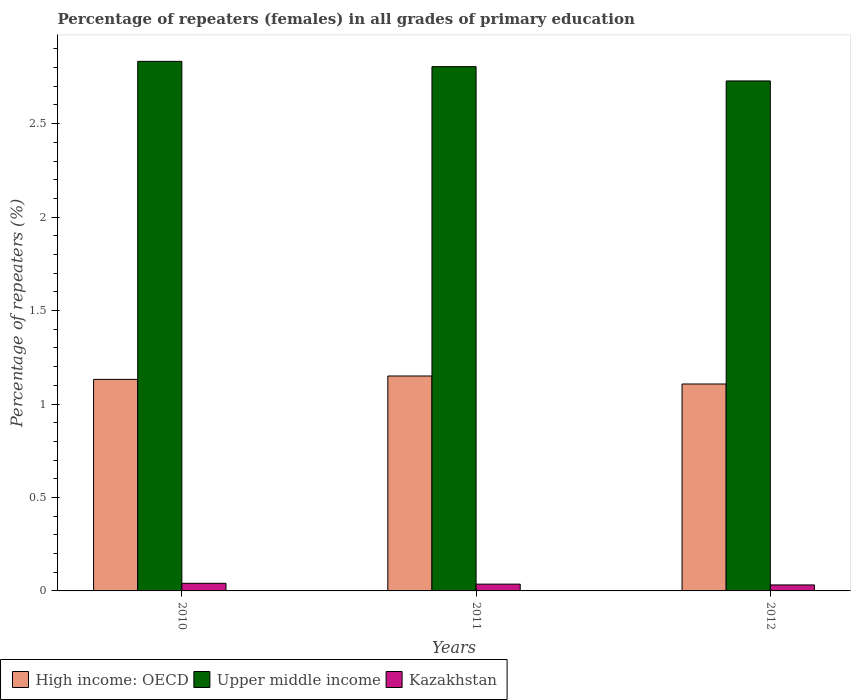How many different coloured bars are there?
Give a very brief answer. 3. What is the label of the 2nd group of bars from the left?
Ensure brevity in your answer.  2011. What is the percentage of repeaters (females) in High income: OECD in 2010?
Your answer should be compact. 1.13. Across all years, what is the maximum percentage of repeaters (females) in Upper middle income?
Give a very brief answer. 2.83. Across all years, what is the minimum percentage of repeaters (females) in Kazakhstan?
Your answer should be compact. 0.03. What is the total percentage of repeaters (females) in Kazakhstan in the graph?
Offer a terse response. 0.11. What is the difference between the percentage of repeaters (females) in Upper middle income in 2011 and that in 2012?
Ensure brevity in your answer.  0.08. What is the difference between the percentage of repeaters (females) in Kazakhstan in 2010 and the percentage of repeaters (females) in High income: OECD in 2012?
Make the answer very short. -1.07. What is the average percentage of repeaters (females) in Upper middle income per year?
Provide a short and direct response. 2.79. In the year 2012, what is the difference between the percentage of repeaters (females) in Upper middle income and percentage of repeaters (females) in High income: OECD?
Keep it short and to the point. 1.62. In how many years, is the percentage of repeaters (females) in Kazakhstan greater than 1.9 %?
Keep it short and to the point. 0. What is the ratio of the percentage of repeaters (females) in Kazakhstan in 2010 to that in 2012?
Keep it short and to the point. 1.27. What is the difference between the highest and the second highest percentage of repeaters (females) in Kazakhstan?
Your response must be concise. 0. What is the difference between the highest and the lowest percentage of repeaters (females) in High income: OECD?
Make the answer very short. 0.04. In how many years, is the percentage of repeaters (females) in Kazakhstan greater than the average percentage of repeaters (females) in Kazakhstan taken over all years?
Keep it short and to the point. 1. Is the sum of the percentage of repeaters (females) in Upper middle income in 2011 and 2012 greater than the maximum percentage of repeaters (females) in Kazakhstan across all years?
Your response must be concise. Yes. What does the 3rd bar from the left in 2011 represents?
Make the answer very short. Kazakhstan. What does the 2nd bar from the right in 2012 represents?
Your response must be concise. Upper middle income. Is it the case that in every year, the sum of the percentage of repeaters (females) in High income: OECD and percentage of repeaters (females) in Upper middle income is greater than the percentage of repeaters (females) in Kazakhstan?
Your answer should be compact. Yes. How many years are there in the graph?
Give a very brief answer. 3. What is the difference between two consecutive major ticks on the Y-axis?
Offer a terse response. 0.5. Does the graph contain any zero values?
Give a very brief answer. No. Does the graph contain grids?
Keep it short and to the point. No. How are the legend labels stacked?
Provide a succinct answer. Horizontal. What is the title of the graph?
Offer a very short reply. Percentage of repeaters (females) in all grades of primary education. Does "Cuba" appear as one of the legend labels in the graph?
Make the answer very short. No. What is the label or title of the X-axis?
Offer a very short reply. Years. What is the label or title of the Y-axis?
Provide a succinct answer. Percentage of repeaters (%). What is the Percentage of repeaters (%) in High income: OECD in 2010?
Your response must be concise. 1.13. What is the Percentage of repeaters (%) of Upper middle income in 2010?
Make the answer very short. 2.83. What is the Percentage of repeaters (%) of Kazakhstan in 2010?
Your answer should be very brief. 0.04. What is the Percentage of repeaters (%) of High income: OECD in 2011?
Your answer should be compact. 1.15. What is the Percentage of repeaters (%) of Upper middle income in 2011?
Provide a succinct answer. 2.81. What is the Percentage of repeaters (%) of Kazakhstan in 2011?
Ensure brevity in your answer.  0.04. What is the Percentage of repeaters (%) of High income: OECD in 2012?
Keep it short and to the point. 1.11. What is the Percentage of repeaters (%) in Upper middle income in 2012?
Make the answer very short. 2.73. What is the Percentage of repeaters (%) in Kazakhstan in 2012?
Your response must be concise. 0.03. Across all years, what is the maximum Percentage of repeaters (%) in High income: OECD?
Make the answer very short. 1.15. Across all years, what is the maximum Percentage of repeaters (%) of Upper middle income?
Provide a succinct answer. 2.83. Across all years, what is the maximum Percentage of repeaters (%) in Kazakhstan?
Offer a very short reply. 0.04. Across all years, what is the minimum Percentage of repeaters (%) of High income: OECD?
Your answer should be very brief. 1.11. Across all years, what is the minimum Percentage of repeaters (%) in Upper middle income?
Ensure brevity in your answer.  2.73. Across all years, what is the minimum Percentage of repeaters (%) of Kazakhstan?
Your answer should be compact. 0.03. What is the total Percentage of repeaters (%) of High income: OECD in the graph?
Offer a terse response. 3.39. What is the total Percentage of repeaters (%) in Upper middle income in the graph?
Offer a terse response. 8.37. What is the total Percentage of repeaters (%) in Kazakhstan in the graph?
Provide a short and direct response. 0.11. What is the difference between the Percentage of repeaters (%) in High income: OECD in 2010 and that in 2011?
Offer a terse response. -0.02. What is the difference between the Percentage of repeaters (%) of Upper middle income in 2010 and that in 2011?
Ensure brevity in your answer.  0.03. What is the difference between the Percentage of repeaters (%) in Kazakhstan in 2010 and that in 2011?
Provide a succinct answer. 0. What is the difference between the Percentage of repeaters (%) of High income: OECD in 2010 and that in 2012?
Provide a succinct answer. 0.02. What is the difference between the Percentage of repeaters (%) of Upper middle income in 2010 and that in 2012?
Keep it short and to the point. 0.1. What is the difference between the Percentage of repeaters (%) of Kazakhstan in 2010 and that in 2012?
Ensure brevity in your answer.  0.01. What is the difference between the Percentage of repeaters (%) in High income: OECD in 2011 and that in 2012?
Your answer should be compact. 0.04. What is the difference between the Percentage of repeaters (%) in Upper middle income in 2011 and that in 2012?
Your response must be concise. 0.08. What is the difference between the Percentage of repeaters (%) of Kazakhstan in 2011 and that in 2012?
Your answer should be very brief. 0. What is the difference between the Percentage of repeaters (%) in High income: OECD in 2010 and the Percentage of repeaters (%) in Upper middle income in 2011?
Provide a short and direct response. -1.67. What is the difference between the Percentage of repeaters (%) of High income: OECD in 2010 and the Percentage of repeaters (%) of Kazakhstan in 2011?
Your response must be concise. 1.1. What is the difference between the Percentage of repeaters (%) in Upper middle income in 2010 and the Percentage of repeaters (%) in Kazakhstan in 2011?
Offer a terse response. 2.8. What is the difference between the Percentage of repeaters (%) of High income: OECD in 2010 and the Percentage of repeaters (%) of Upper middle income in 2012?
Provide a succinct answer. -1.6. What is the difference between the Percentage of repeaters (%) in High income: OECD in 2010 and the Percentage of repeaters (%) in Kazakhstan in 2012?
Give a very brief answer. 1.1. What is the difference between the Percentage of repeaters (%) of Upper middle income in 2010 and the Percentage of repeaters (%) of Kazakhstan in 2012?
Your answer should be very brief. 2.8. What is the difference between the Percentage of repeaters (%) of High income: OECD in 2011 and the Percentage of repeaters (%) of Upper middle income in 2012?
Make the answer very short. -1.58. What is the difference between the Percentage of repeaters (%) in High income: OECD in 2011 and the Percentage of repeaters (%) in Kazakhstan in 2012?
Offer a terse response. 1.12. What is the difference between the Percentage of repeaters (%) of Upper middle income in 2011 and the Percentage of repeaters (%) of Kazakhstan in 2012?
Your response must be concise. 2.77. What is the average Percentage of repeaters (%) of High income: OECD per year?
Offer a very short reply. 1.13. What is the average Percentage of repeaters (%) of Upper middle income per year?
Your response must be concise. 2.79. What is the average Percentage of repeaters (%) in Kazakhstan per year?
Make the answer very short. 0.04. In the year 2010, what is the difference between the Percentage of repeaters (%) of High income: OECD and Percentage of repeaters (%) of Upper middle income?
Ensure brevity in your answer.  -1.7. In the year 2010, what is the difference between the Percentage of repeaters (%) of High income: OECD and Percentage of repeaters (%) of Kazakhstan?
Ensure brevity in your answer.  1.09. In the year 2010, what is the difference between the Percentage of repeaters (%) of Upper middle income and Percentage of repeaters (%) of Kazakhstan?
Offer a very short reply. 2.79. In the year 2011, what is the difference between the Percentage of repeaters (%) in High income: OECD and Percentage of repeaters (%) in Upper middle income?
Give a very brief answer. -1.66. In the year 2011, what is the difference between the Percentage of repeaters (%) in High income: OECD and Percentage of repeaters (%) in Kazakhstan?
Ensure brevity in your answer.  1.11. In the year 2011, what is the difference between the Percentage of repeaters (%) in Upper middle income and Percentage of repeaters (%) in Kazakhstan?
Ensure brevity in your answer.  2.77. In the year 2012, what is the difference between the Percentage of repeaters (%) of High income: OECD and Percentage of repeaters (%) of Upper middle income?
Offer a very short reply. -1.62. In the year 2012, what is the difference between the Percentage of repeaters (%) of High income: OECD and Percentage of repeaters (%) of Kazakhstan?
Your answer should be very brief. 1.07. In the year 2012, what is the difference between the Percentage of repeaters (%) of Upper middle income and Percentage of repeaters (%) of Kazakhstan?
Make the answer very short. 2.7. What is the ratio of the Percentage of repeaters (%) in High income: OECD in 2010 to that in 2011?
Give a very brief answer. 0.98. What is the ratio of the Percentage of repeaters (%) of Kazakhstan in 2010 to that in 2011?
Offer a very short reply. 1.12. What is the ratio of the Percentage of repeaters (%) of High income: OECD in 2010 to that in 2012?
Provide a succinct answer. 1.02. What is the ratio of the Percentage of repeaters (%) of Upper middle income in 2010 to that in 2012?
Provide a short and direct response. 1.04. What is the ratio of the Percentage of repeaters (%) of Kazakhstan in 2010 to that in 2012?
Provide a succinct answer. 1.27. What is the ratio of the Percentage of repeaters (%) in High income: OECD in 2011 to that in 2012?
Keep it short and to the point. 1.04. What is the ratio of the Percentage of repeaters (%) of Upper middle income in 2011 to that in 2012?
Give a very brief answer. 1.03. What is the ratio of the Percentage of repeaters (%) of Kazakhstan in 2011 to that in 2012?
Make the answer very short. 1.13. What is the difference between the highest and the second highest Percentage of repeaters (%) of High income: OECD?
Make the answer very short. 0.02. What is the difference between the highest and the second highest Percentage of repeaters (%) of Upper middle income?
Give a very brief answer. 0.03. What is the difference between the highest and the second highest Percentage of repeaters (%) in Kazakhstan?
Ensure brevity in your answer.  0. What is the difference between the highest and the lowest Percentage of repeaters (%) in High income: OECD?
Provide a succinct answer. 0.04. What is the difference between the highest and the lowest Percentage of repeaters (%) in Upper middle income?
Your response must be concise. 0.1. What is the difference between the highest and the lowest Percentage of repeaters (%) of Kazakhstan?
Ensure brevity in your answer.  0.01. 